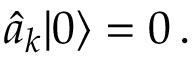<formula> <loc_0><loc_0><loc_500><loc_500>\widehat { a } _ { k } | 0 \rangle = 0 \, .</formula> 